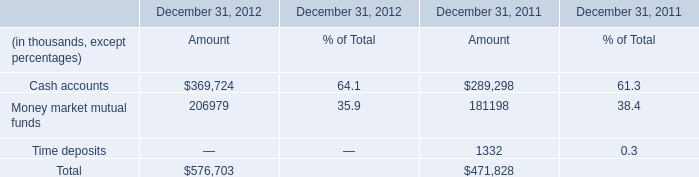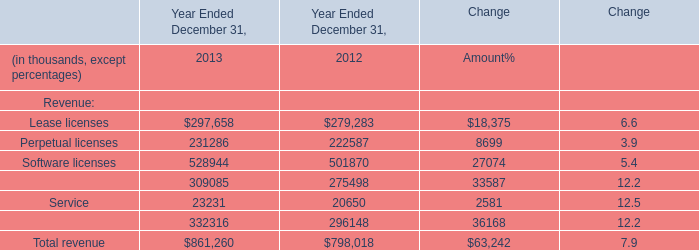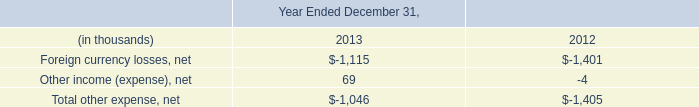what was the percentage decrease in net come for the year ended 2013 to the year ended 2012? 
Computations: ((245.3 - 203.5) / 245.3)
Answer: 0.1704. 